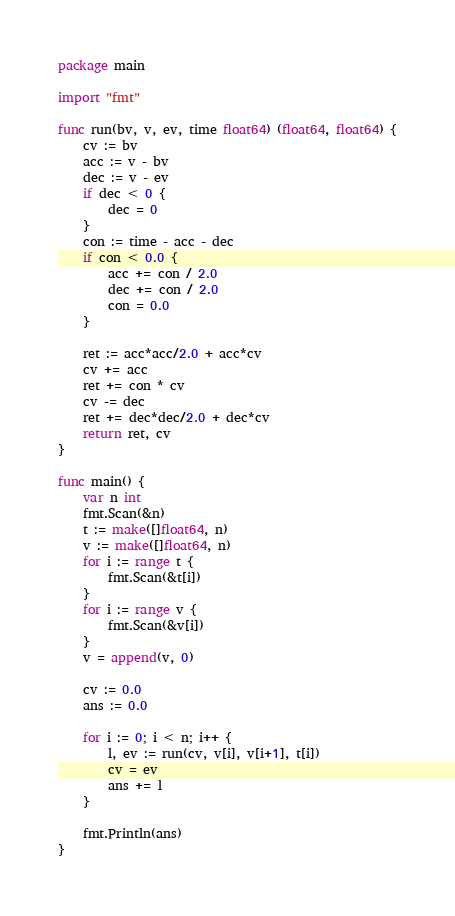<code> <loc_0><loc_0><loc_500><loc_500><_Go_>package main

import "fmt"

func run(bv, v, ev, time float64) (float64, float64) {
	cv := bv
	acc := v - bv
	dec := v - ev
	if dec < 0 {
		dec = 0
	}
	con := time - acc - dec
	if con < 0.0 {
		acc += con / 2.0
		dec += con / 2.0
		con = 0.0
	}

	ret := acc*acc/2.0 + acc*cv
	cv += acc
	ret += con * cv
	cv -= dec
	ret += dec*dec/2.0 + dec*cv
	return ret, cv
}

func main() {
	var n int
	fmt.Scan(&n)
	t := make([]float64, n)
	v := make([]float64, n)
	for i := range t {
		fmt.Scan(&t[i])
	}
	for i := range v {
		fmt.Scan(&v[i])
	}
	v = append(v, 0)

	cv := 0.0
	ans := 0.0

	for i := 0; i < n; i++ {
		l, ev := run(cv, v[i], v[i+1], t[i])
		cv = ev
		ans += l
	}

	fmt.Println(ans)
}
</code> 